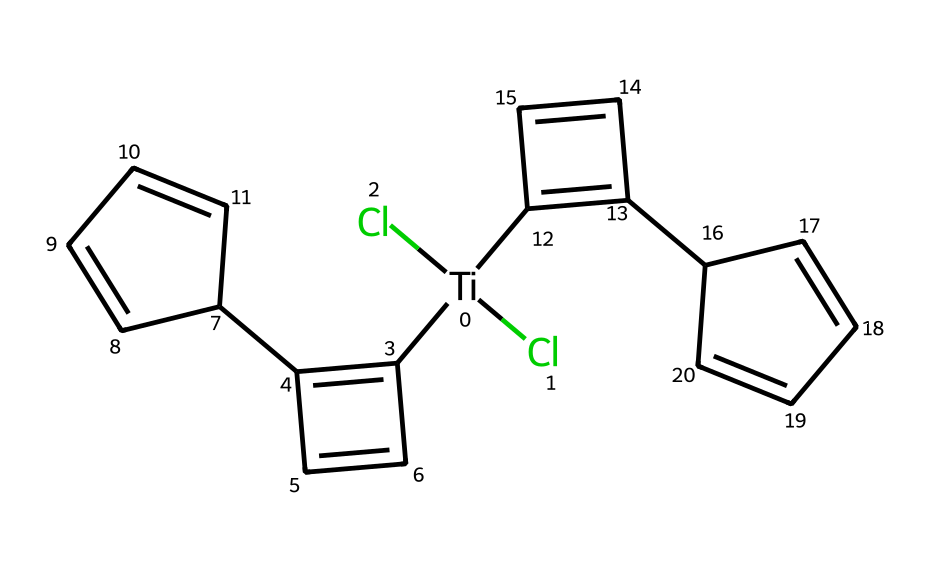What is the central metal atom in titanocene dichloride? The SMILES representation includes a titanium atom representation at the beginning. The notation [Ti] indicates titanium is the central metal atom in the structure.
Answer: titanium How many chlorine atoms are present in the structure? In the SMILES, there are two instances of (Cl), indicating that there are two chlorine atoms bonded to the central titanium atom.
Answer: two What is the total number of carbon atoms in titanocene dichloride? By analyzing the structure represented by the SMILES, every carbon atom is represented as 'C', and in total, there are 16 carbon atoms visible, combining all segments of the structure.
Answer: sixteen What type of chemical bonds are present between titanium and chlorine in this structure? The connection between titanium and chlorine is signified by the parenthesis enclosing Cl: (Cl)(Cl), which represents covalent bonds formed between the titanium atom and each chlorine atom.
Answer: covalent How many rings are present in the molecular structure of titanocene dichloride? The compound features multiple carbon chains forming distinct cyclical structures based on the connections and arrangement of the carbon atoms outlined in the SMILES, leading to a conclusion of three rings.
Answer: three What is the stereochemistry of the cyclohexene-like structure in titanocene dichloride? The SMILES notation contains stereocenters labeled with @, indicating that there are specific stereochemical configurations at those points, which means the structure has defined stereoisomerism.
Answer: chiral Which class of organometallic compounds does titanocene dichloride belong to? The presence of a titanium center bonded to organic groups (aromatic rings) and halogens classifies titanocene dichloride as a metallocene, which is a subclass of organometallic compounds.
Answer: metallocene 